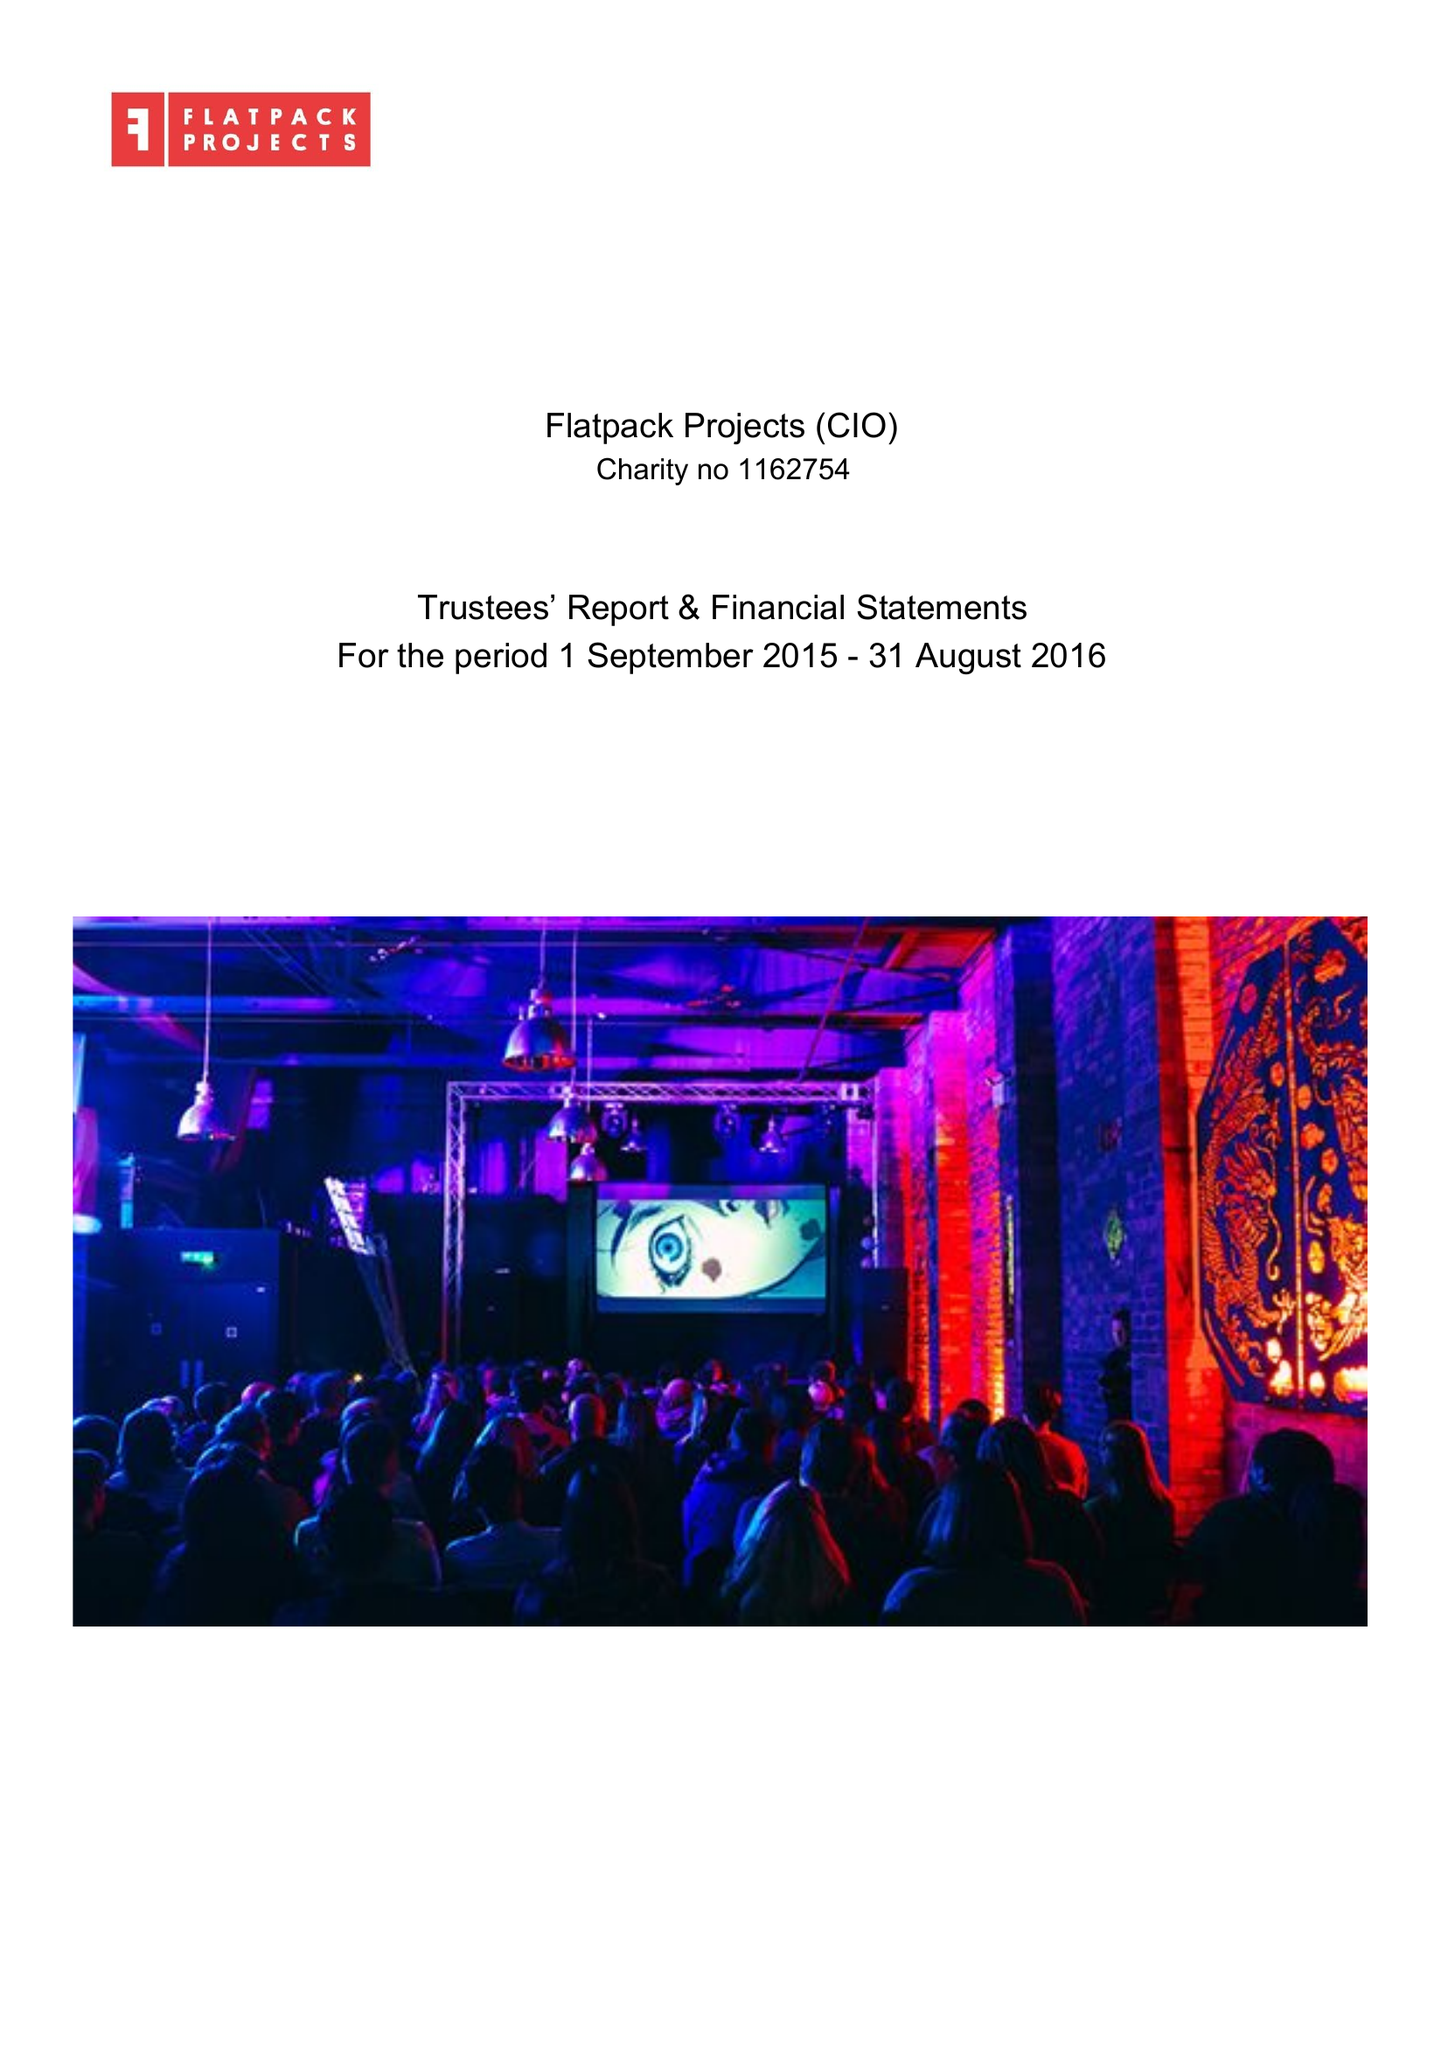What is the value for the income_annually_in_british_pounds?
Answer the question using a single word or phrase. 374626.00 